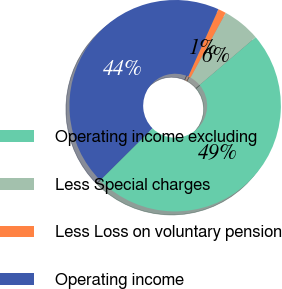Convert chart to OTSL. <chart><loc_0><loc_0><loc_500><loc_500><pie_chart><fcel>Operating income excluding<fcel>Less Special charges<fcel>Less Loss on voluntary pension<fcel>Operating income<nl><fcel>48.77%<fcel>5.84%<fcel>1.23%<fcel>44.16%<nl></chart> 